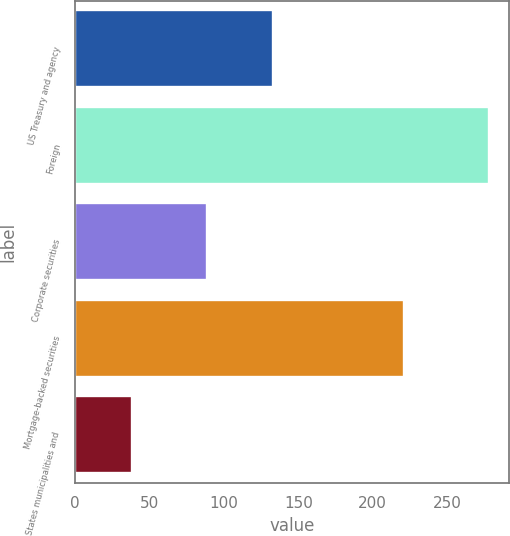<chart> <loc_0><loc_0><loc_500><loc_500><bar_chart><fcel>US Treasury and agency<fcel>Foreign<fcel>Corporate securities<fcel>Mortgage-backed securities<fcel>States municipalities and<nl><fcel>133<fcel>278<fcel>89<fcel>221<fcel>38<nl></chart> 